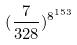Convert formula to latex. <formula><loc_0><loc_0><loc_500><loc_500>( \frac { 7 } { 3 2 8 } ) ^ { 8 ^ { 1 5 3 } }</formula> 